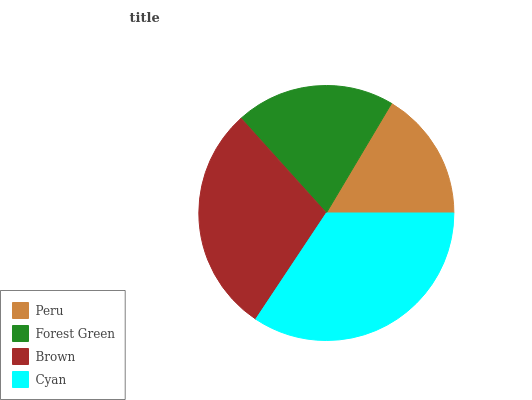Is Peru the minimum?
Answer yes or no. Yes. Is Cyan the maximum?
Answer yes or no. Yes. Is Forest Green the minimum?
Answer yes or no. No. Is Forest Green the maximum?
Answer yes or no. No. Is Forest Green greater than Peru?
Answer yes or no. Yes. Is Peru less than Forest Green?
Answer yes or no. Yes. Is Peru greater than Forest Green?
Answer yes or no. No. Is Forest Green less than Peru?
Answer yes or no. No. Is Brown the high median?
Answer yes or no. Yes. Is Forest Green the low median?
Answer yes or no. Yes. Is Peru the high median?
Answer yes or no. No. Is Brown the low median?
Answer yes or no. No. 